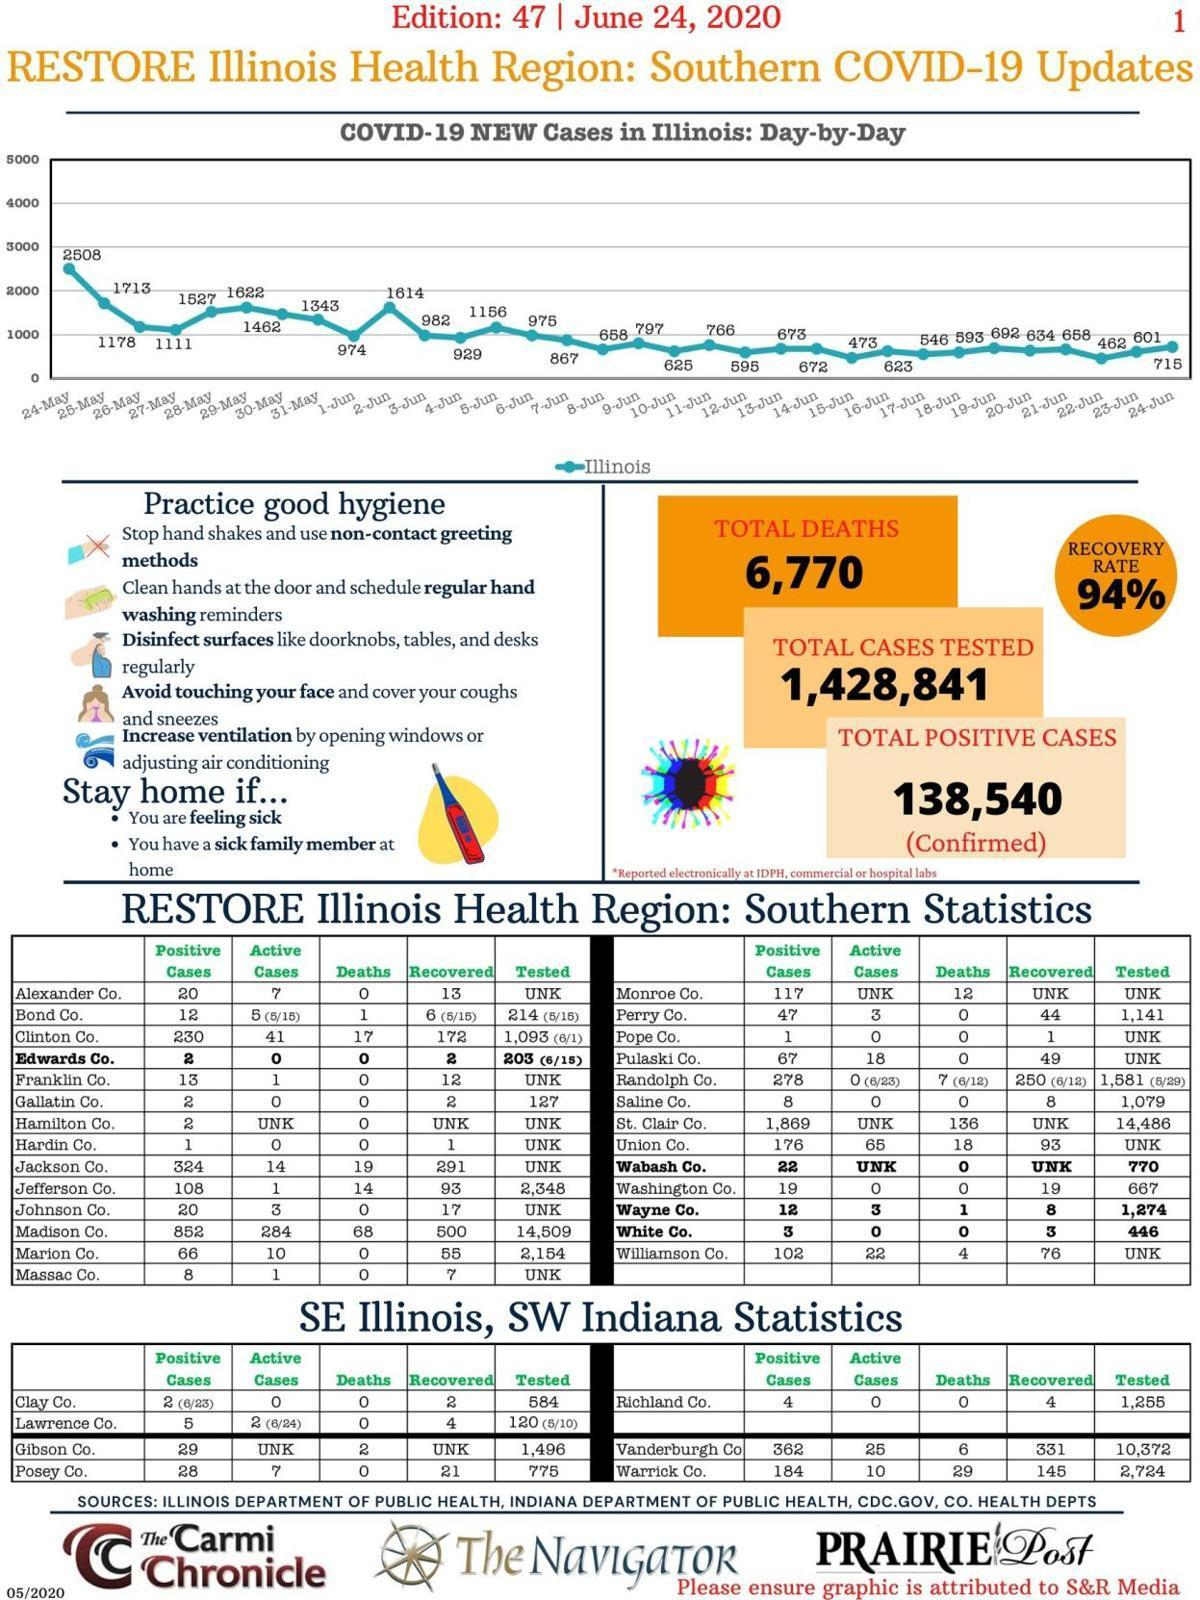What is the total number of active cases in Clay Co. and Posey Co., taken together?
Answer the question with a short phrase. 7 What is the total number of deaths in Bond Co. and Madison Co., taken together? 69 What is the total number of active cases in Jackson Co. and Johnson Co., taken together? 17 What is the total number of positive cases in Bond Co. and Massac Co., taken together? 20 What is the total number of cases on the 23rd and 24th of June, taken together? 1316 What is the total negative cases? 1,290,301 What is the total number of cases on the 24th and 25th of May, taken together? 4221 